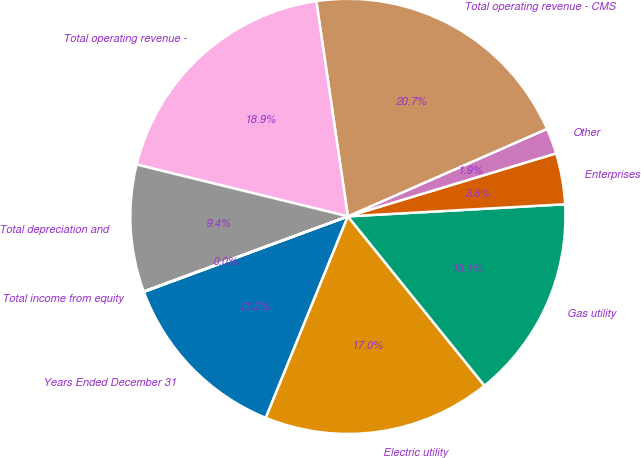<chart> <loc_0><loc_0><loc_500><loc_500><pie_chart><fcel>Years Ended December 31<fcel>Electric utility<fcel>Gas utility<fcel>Enterprises<fcel>Other<fcel>Total operating revenue - CMS<fcel>Total operating revenue -<fcel>Total depreciation and<fcel>Total income from equity<nl><fcel>13.2%<fcel>16.96%<fcel>15.08%<fcel>3.79%<fcel>1.91%<fcel>20.73%<fcel>18.85%<fcel>9.44%<fcel>0.03%<nl></chart> 